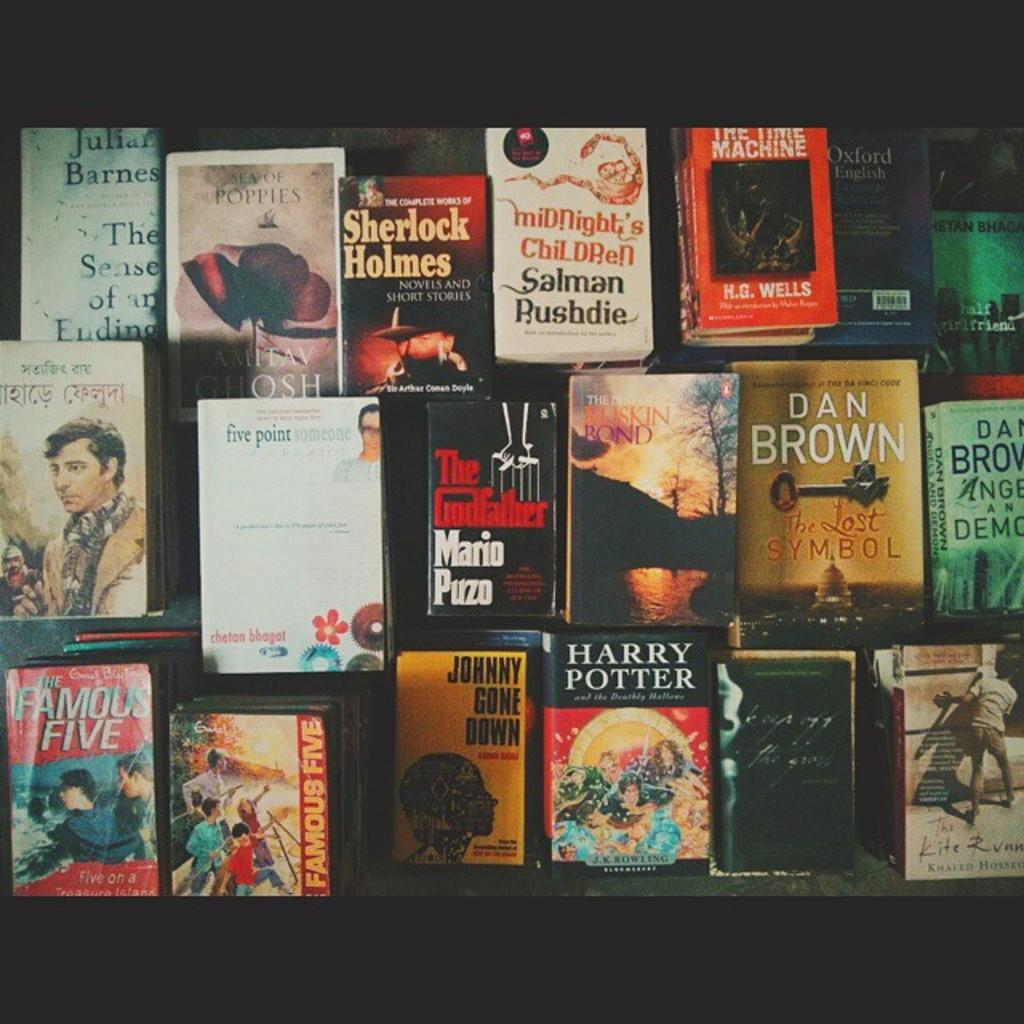<image>
Offer a succinct explanation of the picture presented. A group of books with at least one by Dan Brown. 